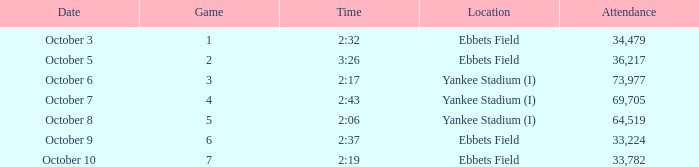What is the location of the game that has a number smaller than 2? Ebbets Field. 